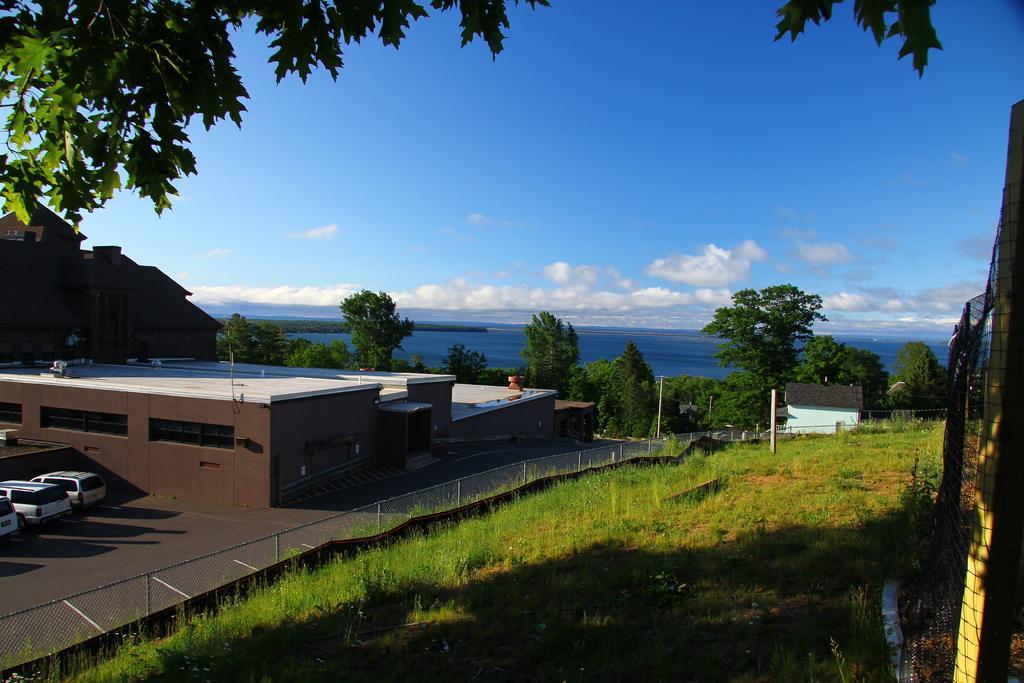Could you give a brief overview of what you see in this image? In this image in the front there's grass on the ground. In the center there is a fence. In the background there are buildings, cars, trees, there is water and the sky is cloudy. 